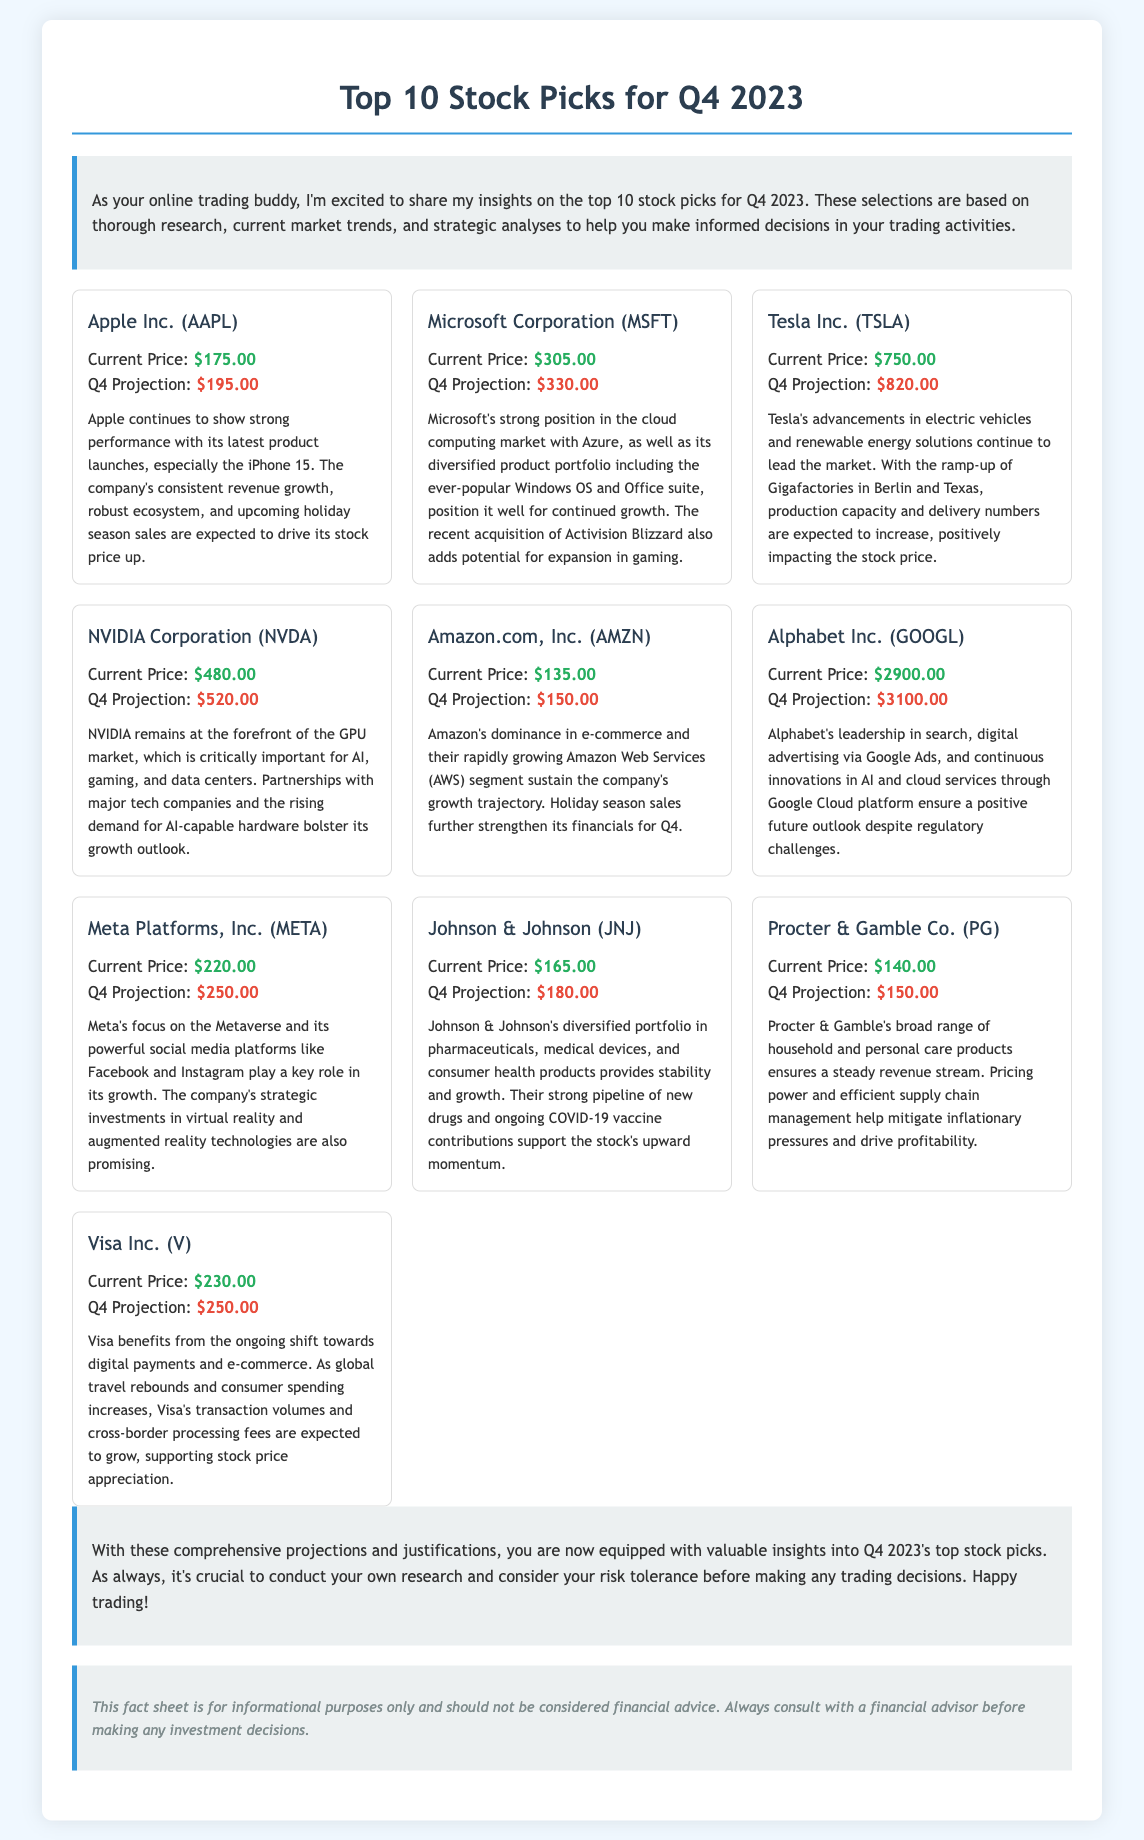What is the current price of Apple Inc.? The current price of Apple Inc. (AAPL) is stated in the document under the respective stock card.
Answer: $175.00 What is the Q4 projection for Microsoft Corporation? The Q4 projection for Microsoft Corporation (MSFT) can be found in the stock card section related to Microsoft.
Answer: $330.00 Which company has the highest current stock price listed? To determine the company with the highest current stock price, we can compare the current prices of all companies listed in the document.
Answer: Alphabet Inc. (GOOGL) What factor is driving Apple's stock price up? The justification for Apple's projected stock price includes several factors, and one key factor is indicated.
Answer: Latest product launches, especially the iPhone 15 What is the justification for Visa Inc.'s projected stock price increase? The justification section of Visa Inc.'s stock card outlines specific drivers for its stock projection.
Answer: Ongoing shift towards digital payments and e-commerce How many companies are listed in this document? The document details a list of companies that provide stock picks for Q4 2023, making it easy to count them.
Answer: 10 What is one reason for Tesla's projected stock price increase? The justification provided for Tesla includes factors that support its expected stock price rise, specifically focusing on its operations.
Answer: Advancements in electric vehicles What does the disclaimer advise regarding investment decisions? The disclaimer found at the end of the document emphasizes a certain approach when it comes to investment decisions.
Answer: Consult with a financial advisor What is the primary focus of Meta Platforms, Inc. according to the fact sheet? The justification details Meta Platforms' strategic focus, which provides insight into its growth initiatives.
Answer: The Metaverse 